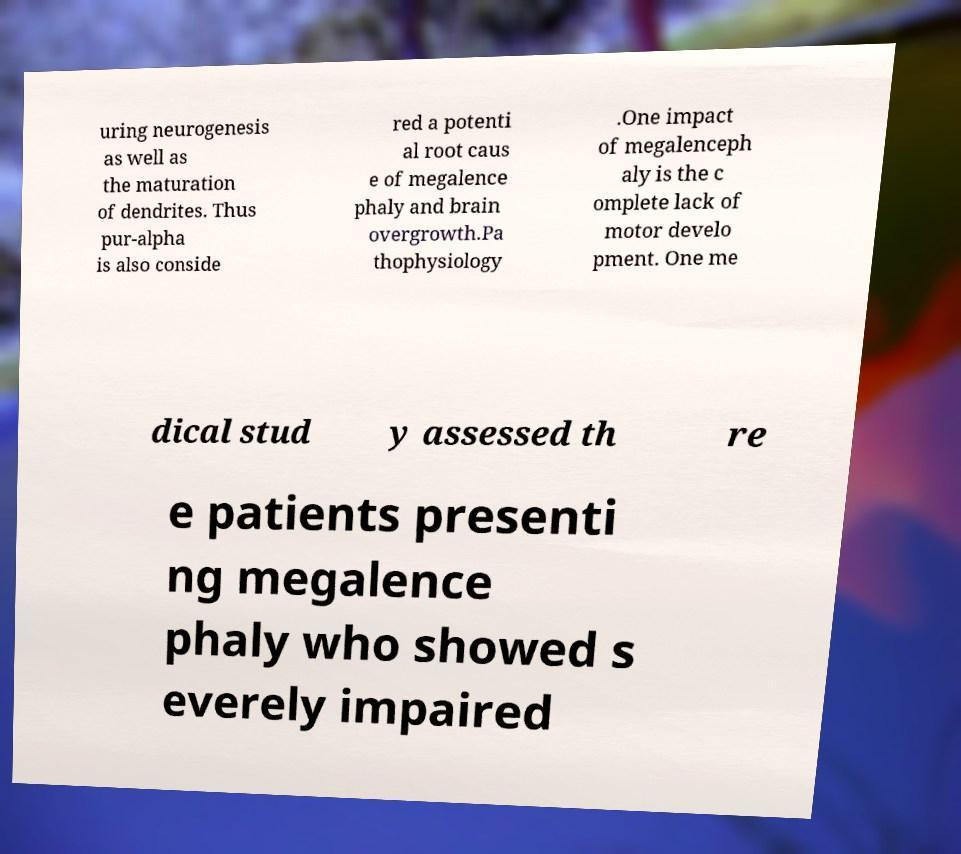Could you extract and type out the text from this image? uring neurogenesis as well as the maturation of dendrites. Thus pur-alpha is also conside red a potenti al root caus e of megalence phaly and brain overgrowth.Pa thophysiology .One impact of megalenceph aly is the c omplete lack of motor develo pment. One me dical stud y assessed th re e patients presenti ng megalence phaly who showed s everely impaired 